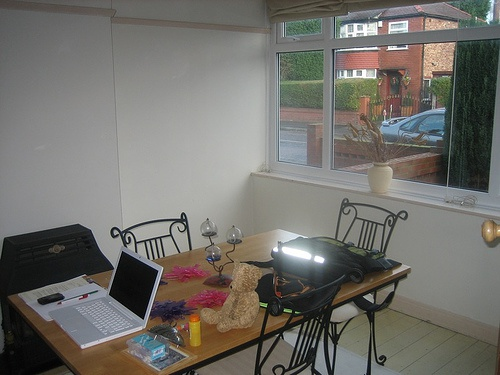Describe the objects in this image and their specific colors. I can see dining table in black, maroon, and gray tones, laptop in black, darkgray, and gray tones, chair in black, gray, and maroon tones, chair in black and gray tones, and teddy bear in black, gray, and tan tones in this image. 